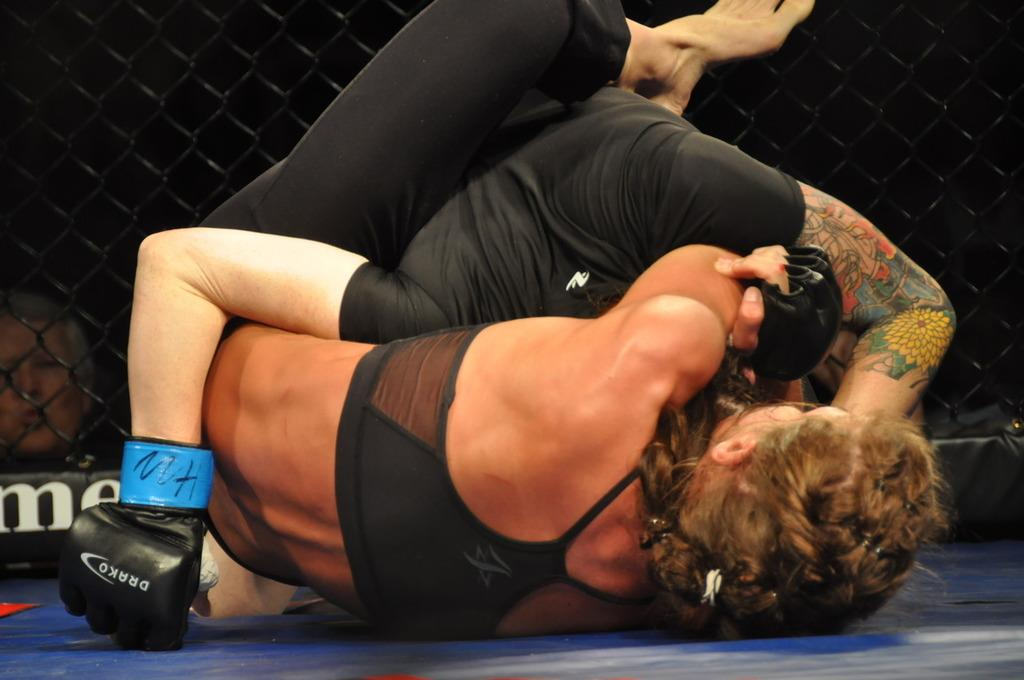<image>
Present a compact description of the photo's key features. A woman with a Drako glove wrestles another woman. 